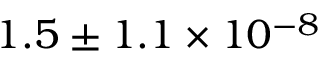<formula> <loc_0><loc_0><loc_500><loc_500>1 . 5 \pm 1 . 1 \times 1 0 ^ { - 8 }</formula> 